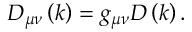Convert formula to latex. <formula><loc_0><loc_0><loc_500><loc_500>D _ { \mu \nu } \left ( k \right ) = g _ { \mu \nu } D \left ( k \right ) .</formula> 